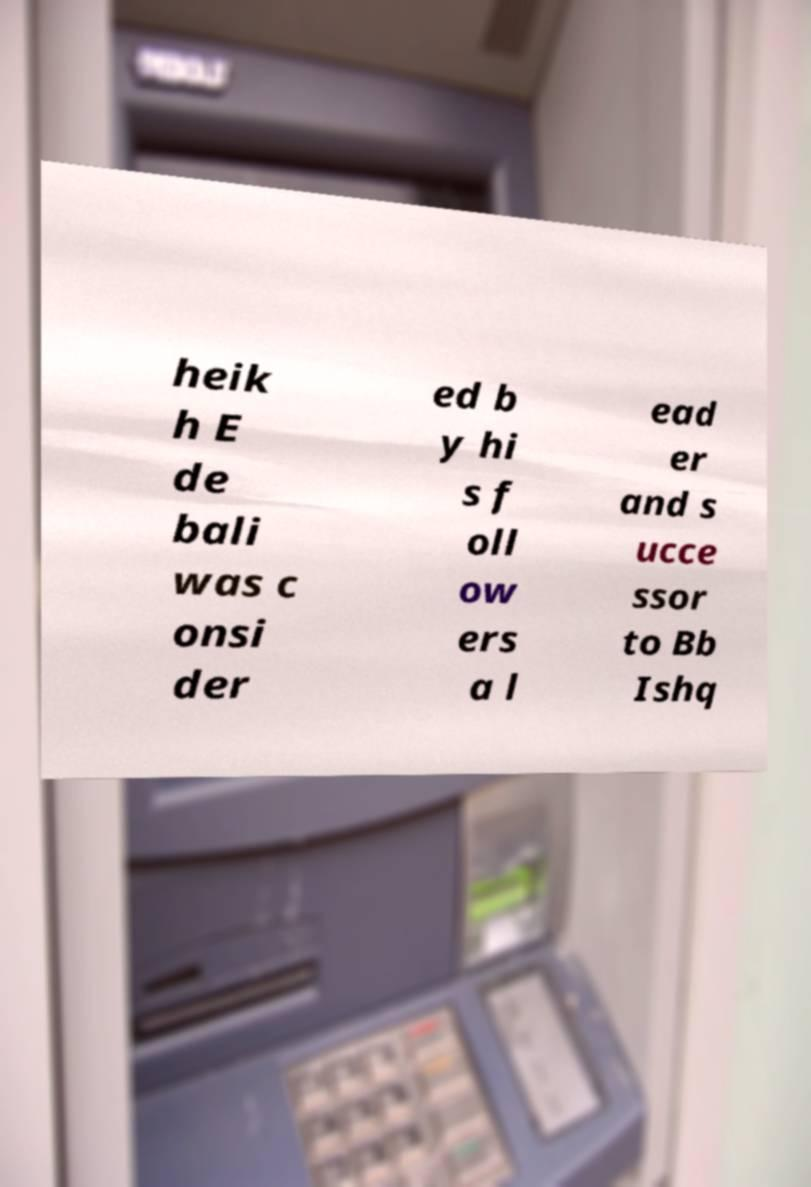Could you assist in decoding the text presented in this image and type it out clearly? heik h E de bali was c onsi der ed b y hi s f oll ow ers a l ead er and s ucce ssor to Bb Ishq 